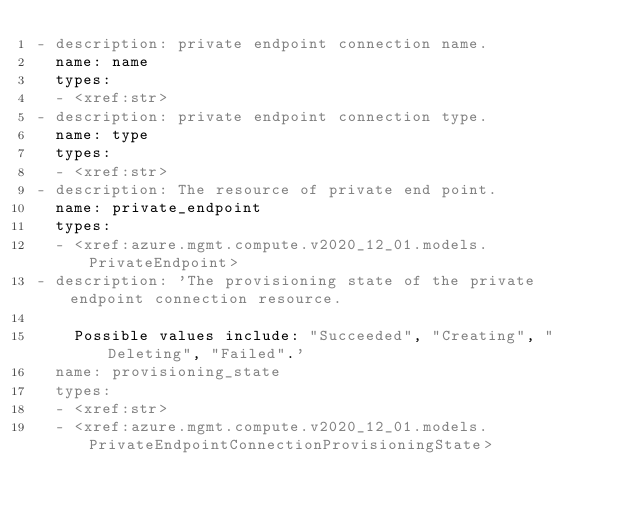Convert code to text. <code><loc_0><loc_0><loc_500><loc_500><_YAML_>- description: private endpoint connection name.
  name: name
  types:
  - <xref:str>
- description: private endpoint connection type.
  name: type
  types:
  - <xref:str>
- description: The resource of private end point.
  name: private_endpoint
  types:
  - <xref:azure.mgmt.compute.v2020_12_01.models.PrivateEndpoint>
- description: 'The provisioning state of the private endpoint connection resource.

    Possible values include: "Succeeded", "Creating", "Deleting", "Failed".'
  name: provisioning_state
  types:
  - <xref:str>
  - <xref:azure.mgmt.compute.v2020_12_01.models.PrivateEndpointConnectionProvisioningState>
</code> 